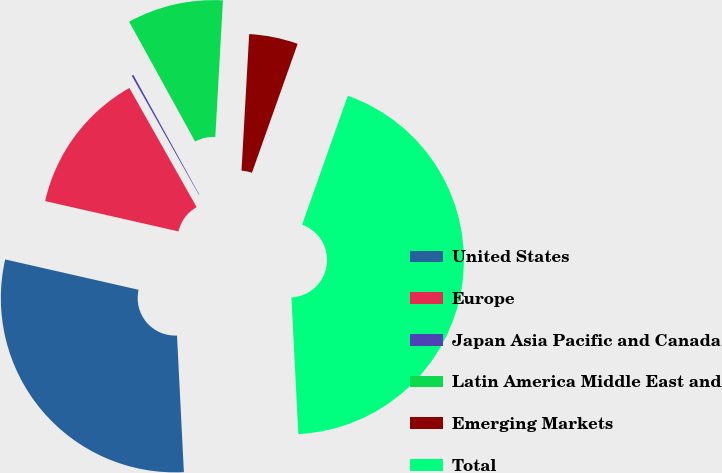Convert chart to OTSL. <chart><loc_0><loc_0><loc_500><loc_500><pie_chart><fcel>United States<fcel>Europe<fcel>Japan Asia Pacific and Canada<fcel>Latin America Middle East and<fcel>Emerging Markets<fcel>Total<nl><fcel>29.36%<fcel>13.26%<fcel>0.17%<fcel>8.9%<fcel>4.53%<fcel>43.78%<nl></chart> 